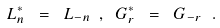<formula> <loc_0><loc_0><loc_500><loc_500>L _ { n } ^ { * } \ = \ L _ { - n } \ , \ G _ { r } ^ { * } \ = \ G _ { - r } \ .</formula> 